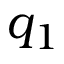<formula> <loc_0><loc_0><loc_500><loc_500>q _ { 1 }</formula> 